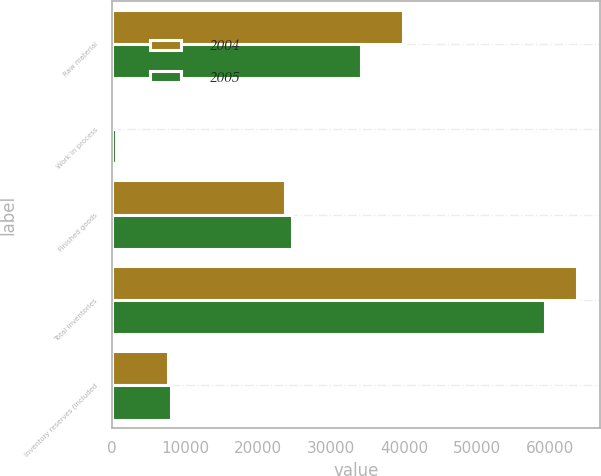Convert chart to OTSL. <chart><loc_0><loc_0><loc_500><loc_500><stacked_bar_chart><ecel><fcel>Raw material<fcel>Work in process<fcel>Finished goods<fcel>Total inventories<fcel>Inventory reserves (included<nl><fcel>2004<fcel>39779<fcel>134<fcel>23725<fcel>63638<fcel>7598<nl><fcel>2005<fcel>34041<fcel>569<fcel>24645<fcel>59255<fcel>8037<nl></chart> 